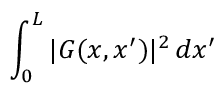Convert formula to latex. <formula><loc_0><loc_0><loc_500><loc_500>\int _ { 0 } ^ { L } | G ( x , x ^ { \prime } ) | ^ { 2 } \, d x ^ { \prime }</formula> 